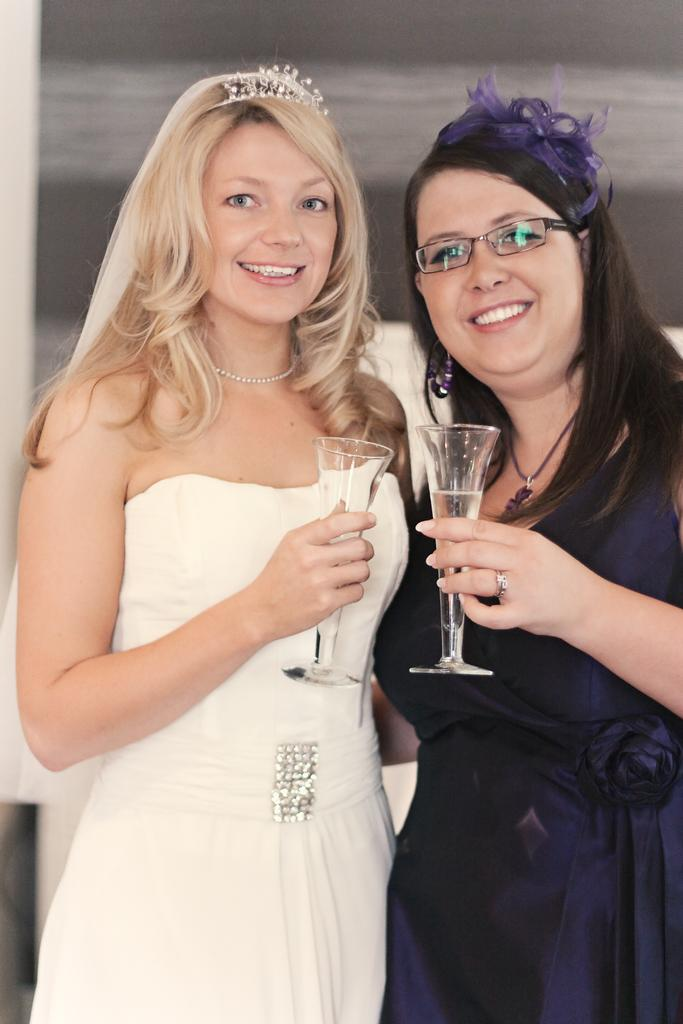How many people are in the image? There are two women in the image. What are the women doing in the image? The women are standing and smiling. What are the women holding in the image? The women are holding a glass each. What can be seen in the background of the image? There is a wall in the background of the image. What type of celery is being used to cook in the image? There is no celery or cooking activity present in the image. How does the cook show the dish to the audience in the image? There is no cook or dish being shown to an audience in the image. 